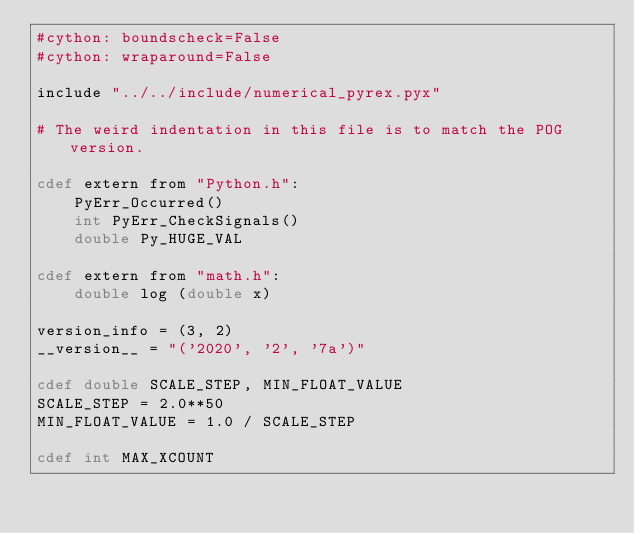<code> <loc_0><loc_0><loc_500><loc_500><_Cython_>#cython: boundscheck=False
#cython: wraparound=False

include "../../include/numerical_pyrex.pyx"

# The weird indentation in this file is to match the POG version.

cdef extern from "Python.h":
    PyErr_Occurred()
    int PyErr_CheckSignals()
    double Py_HUGE_VAL

cdef extern from "math.h":
    double log (double x)

version_info = (3, 2)
__version__ = "('2020', '2', '7a')"

cdef double SCALE_STEP, MIN_FLOAT_VALUE
SCALE_STEP = 2.0**50
MIN_FLOAT_VALUE = 1.0 / SCALE_STEP

cdef int MAX_XCOUNT</code> 